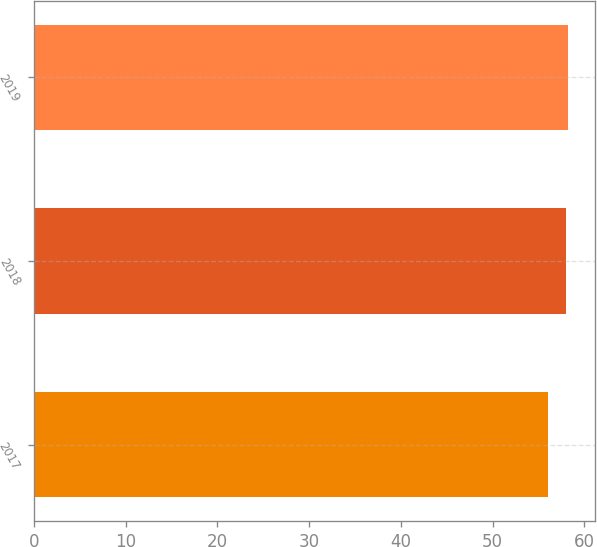<chart> <loc_0><loc_0><loc_500><loc_500><bar_chart><fcel>2017<fcel>2018<fcel>2019<nl><fcel>56<fcel>58<fcel>58.2<nl></chart> 